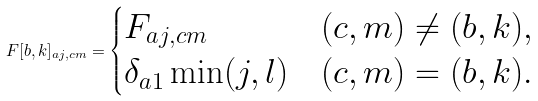Convert formula to latex. <formula><loc_0><loc_0><loc_500><loc_500>F [ b , k ] _ { a j , c m } = \begin{cases} F _ { a j , c m } & ( c , m ) \neq ( b , k ) , \\ \delta _ { a 1 } \min ( j , l ) & ( c , m ) = ( b , k ) . \end{cases}</formula> 